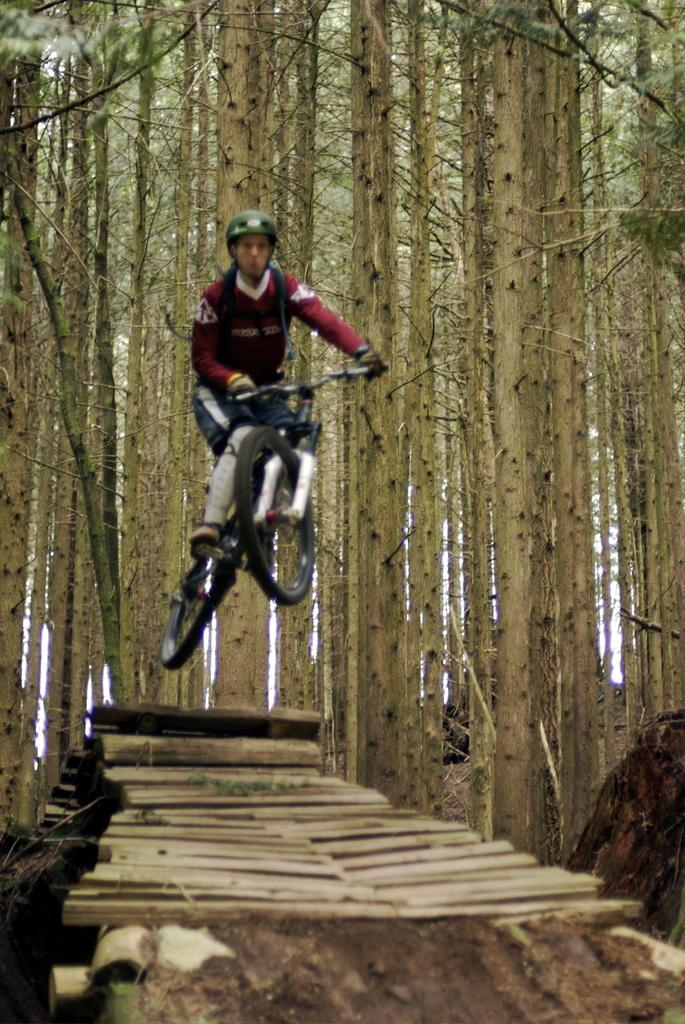What type of path can be seen in the forest in the image? There is a wooden sticks path in the forest in the image. What is the man doing in the image? The man is jumping with a bicycle. What type of clothing is the man wearing? The man is wearing a T-shirt. What safety gear is the man wearing? The man is wearing a helmet. What can be seen in the background of the image? There are trees in the background of the image. Can you tell me how many plane tickets the man has purchased for his trip? There is no mention of plane tickets or a trip in the image, so it is not possible to answer that question. What is the man trying to increase in the image? There is no indication of the man trying to increase anything in the image. 